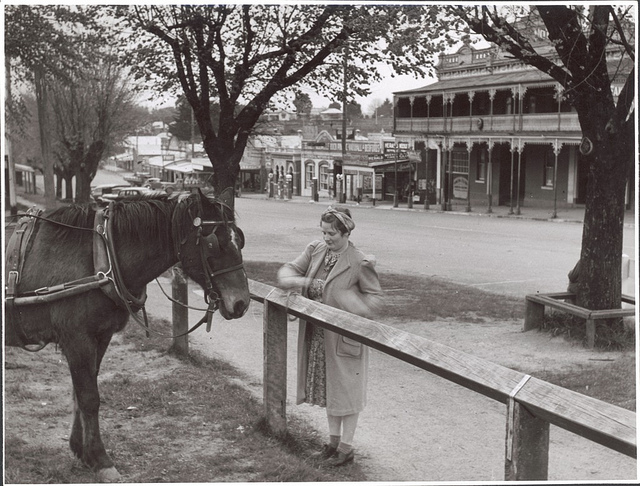<image>What year was this picture taken? It is unknown what year this picture was taken. What is the horse strapped to? I don't know what horse is strapped to. It could be a fence, wood, saddle, wagon, buggy, pole, or harness. What year was this picture taken? I don't know what year this picture was taken. It is not clear based on the given answers. What is the horse strapped to? I am not sure what the horse is strapped to. It can be seen strapped to a fence, wood, or a saddle. 